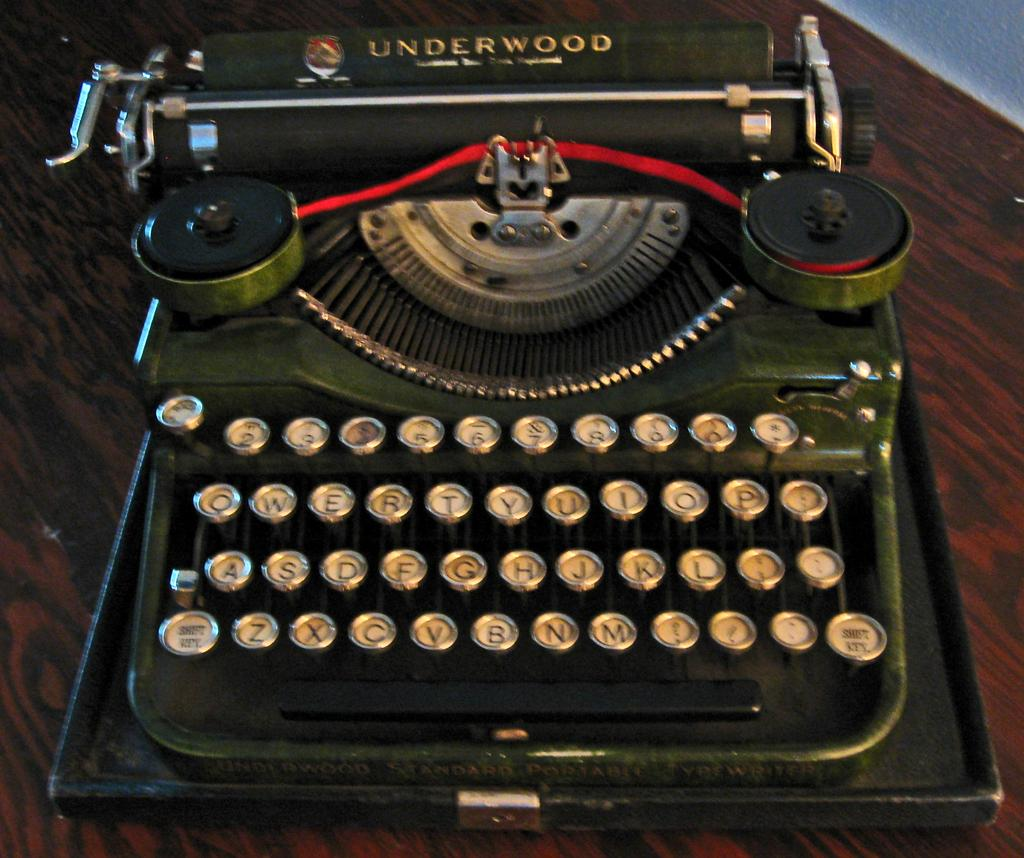<image>
Provide a brief description of the given image. The antique green typewriter on the desk is an Underwood brand. 